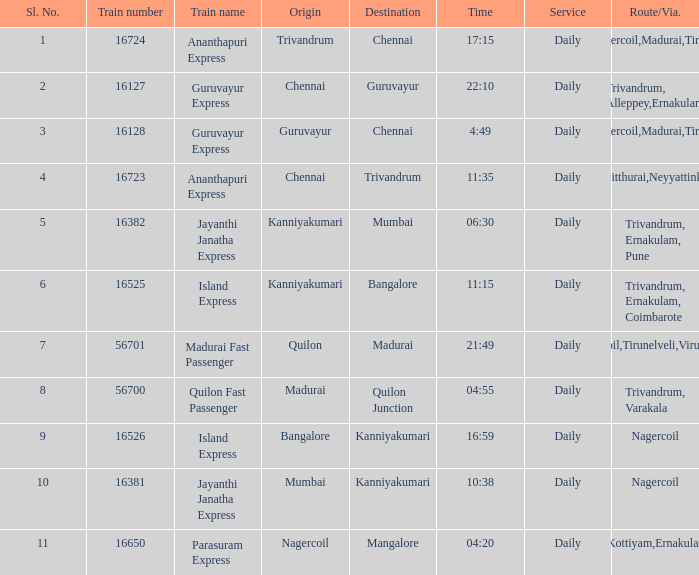What train number corresponds to a time of 10:38? 16381.0. Write the full table. {'header': ['Sl. No.', 'Train number', 'Train name', 'Origin', 'Destination', 'Time', 'Service', 'Route/Via.'], 'rows': [['1', '16724', 'Ananthapuri Express', 'Trivandrum', 'Chennai', '17:15', 'Daily', 'Nagercoil,Madurai,Tiruchi'], ['2', '16127', 'Guruvayur Express', 'Chennai', 'Guruvayur', '22:10', 'Daily', 'Trivandrum, Alleppey,Ernakulam'], ['3', '16128', 'Guruvayur Express', 'Guruvayur', 'Chennai', '4:49', 'Daily', 'Nagercoil,Madurai,Tiruchi'], ['4', '16723', 'Ananthapuri Express', 'Chennai', 'Trivandrum', '11:35', 'Daily', 'Kulitthurai,Neyyattinkara'], ['5', '16382', 'Jayanthi Janatha Express', 'Kanniyakumari', 'Mumbai', '06:30', 'Daily', 'Trivandrum, Ernakulam, Pune'], ['6', '16525', 'Island Express', 'Kanniyakumari', 'Bangalore', '11:15', 'Daily', 'Trivandrum, Ernakulam, Coimbarote'], ['7', '56701', 'Madurai Fast Passenger', 'Quilon', 'Madurai', '21:49', 'Daily', 'Nagercoil,Tirunelveli,Virudunagar'], ['8', '56700', 'Quilon Fast Passenger', 'Madurai', 'Quilon Junction', '04:55', 'Daily', 'Trivandrum, Varakala'], ['9', '16526', 'Island Express', 'Bangalore', 'Kanniyakumari', '16:59', 'Daily', 'Nagercoil'], ['10', '16381', 'Jayanthi Janatha Express', 'Mumbai', 'Kanniyakumari', '10:38', 'Daily', 'Nagercoil'], ['11', '16650', 'Parasuram Express', 'Nagercoil', 'Mangalore', '04:20', 'Daily', 'Trivandrum,Kottiyam,Ernakulam,Kozhikode']]} 